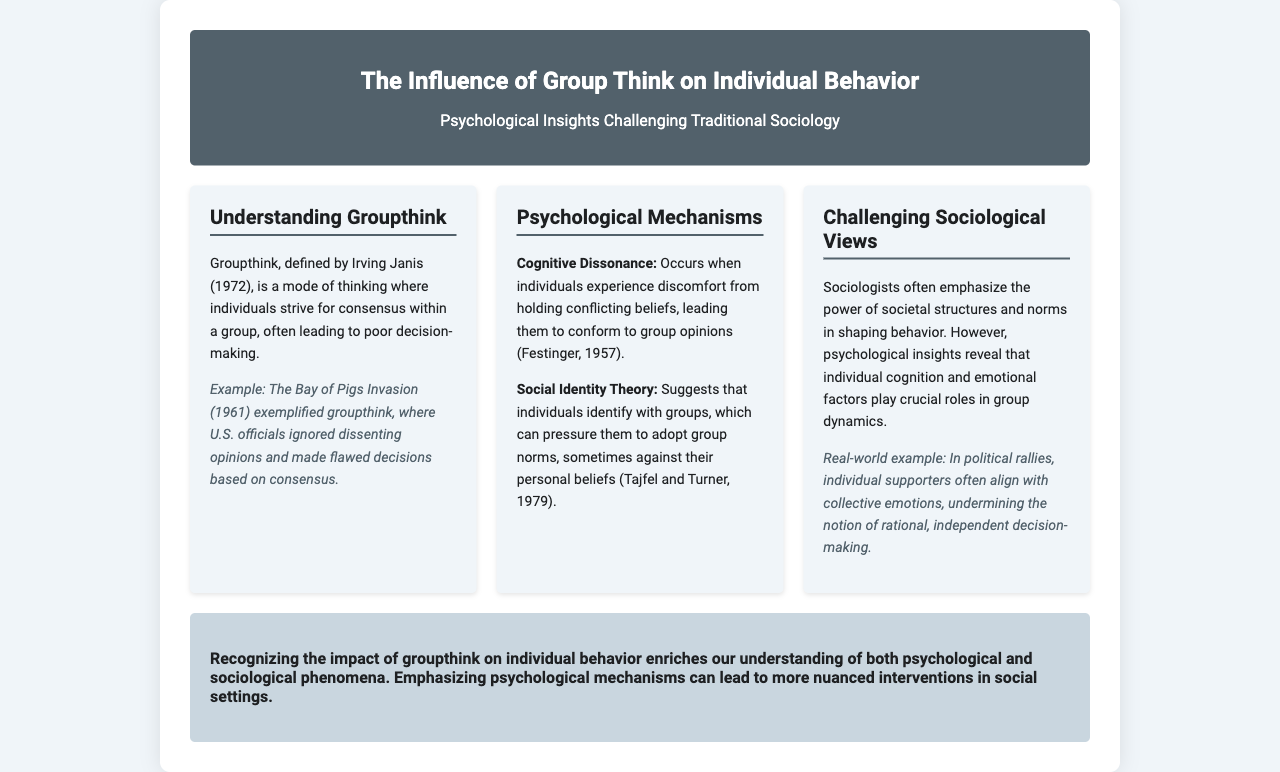What is groupthink? Groupthink is defined as a mode of thinking where individuals strive for consensus within a group, leading to poor decision-making.
Answer: a mode of thinking Who defined groupthink? The brochure states that groupthink was defined by Irving Janis.
Answer: Irving Janis What year was the Bay of Pigs Invasion? The brochure mentions the Bay of Pigs Invasion occurred in 1961.
Answer: 1961 What psychological mechanism involves discomfort from conflicting beliefs? The document refers to cognitive dissonance as the mechanism for this discomfort.
Answer: cognitive dissonance Which theory suggests individuals identify with groups? Social Identity Theory is the theory mentioned in the document that relates to group identification.
Answer: Social Identity Theory What are sociologists emphasized to shape behavior? The document indicates that sociologists emphasize societal structures and norms.
Answer: societal structures and norms What example is provided for challenging sociological views? The example related to challenging sociological views is political rallies.
Answer: political rallies What does recognizing the impact of groupthink enrich? It enriches our understanding of both psychological and sociological phenomena.
Answer: understanding What is a potential outcome of emphasizing psychological mechanisms? The brochure suggests it can lead to more nuanced interventions in social settings.
Answer: nuanced interventions 